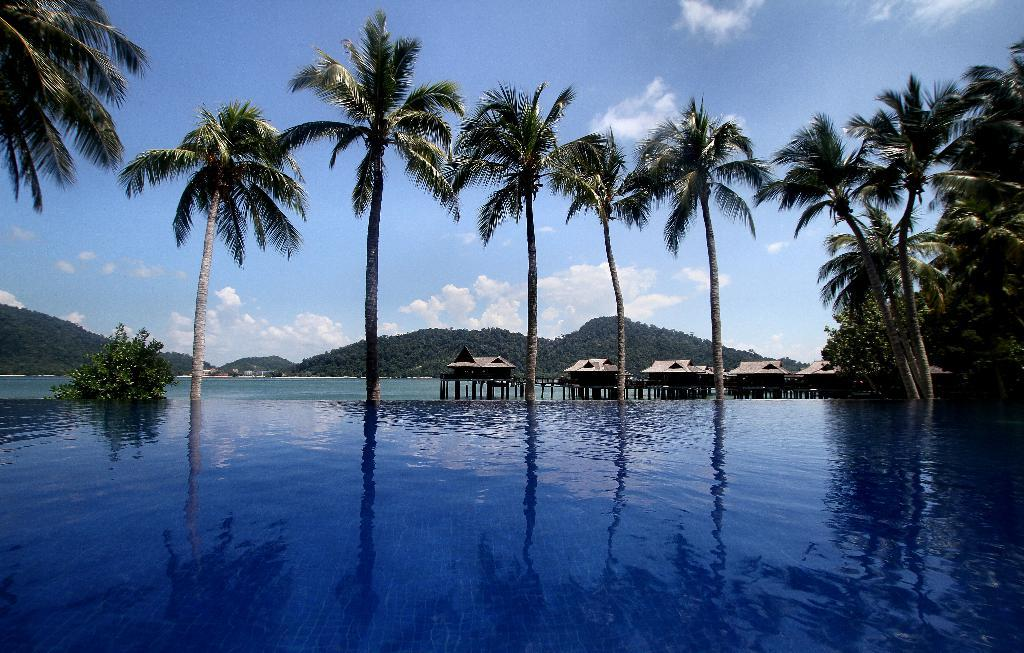What can be seen in the middle of the image? There are trees, houses, a bridge, and water in the middle of the image. What type of landscape feature is present in the middle of the image? A bridge is present in the middle of the image. What is visible in the background of the image? Hills, sky, and clouds are visible in the background of the image. What type of tub can be seen in the image? There is no tub present in the image. What is the breakfast item featured in the image? There is no breakfast item featured in the image. 